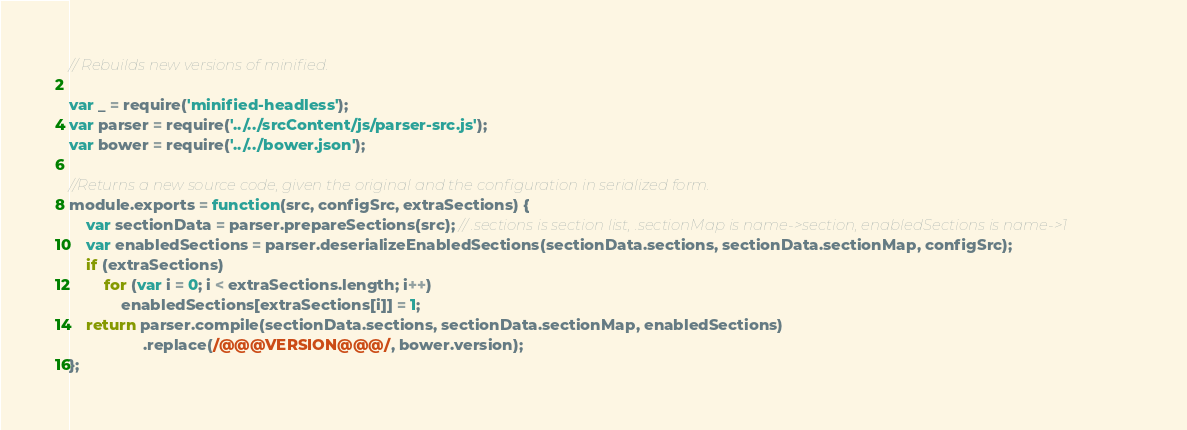<code> <loc_0><loc_0><loc_500><loc_500><_JavaScript_>// Rebuilds new versions of minified.

var _ = require('minified-headless');
var parser = require('../../srcContent/js/parser-src.js');
var bower = require('../../bower.json');

//Returns a new source code, given the original and the configuration in serialized form.
module.exports = function(src, configSrc, extraSections) {
	var sectionData = parser.prepareSections(src); // .sections is section list, .sectionMap is name->section, enabledSections is name->1
	var enabledSections = parser.deserializeEnabledSections(sectionData.sections, sectionData.sectionMap, configSrc);
	if (extraSections)
		for (var i = 0; i < extraSections.length; i++)
			enabledSections[extraSections[i]] = 1;
	return parser.compile(sectionData.sections, sectionData.sectionMap, enabledSections)
	             .replace(/@@@VERSION@@@/, bower.version);
};
</code> 